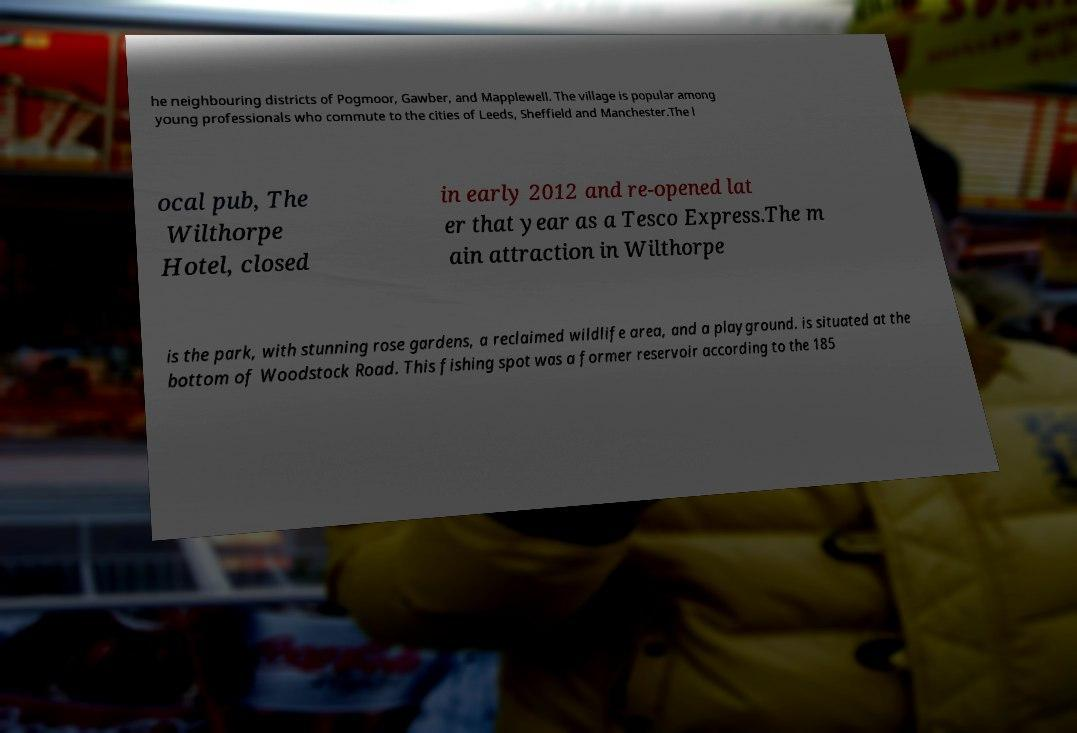Can you accurately transcribe the text from the provided image for me? he neighbouring districts of Pogmoor, Gawber, and Mapplewell. The village is popular among young professionals who commute to the cities of Leeds, Sheffield and Manchester.The l ocal pub, The Wilthorpe Hotel, closed in early 2012 and re-opened lat er that year as a Tesco Express.The m ain attraction in Wilthorpe is the park, with stunning rose gardens, a reclaimed wildlife area, and a playground. is situated at the bottom of Woodstock Road. This fishing spot was a former reservoir according to the 185 